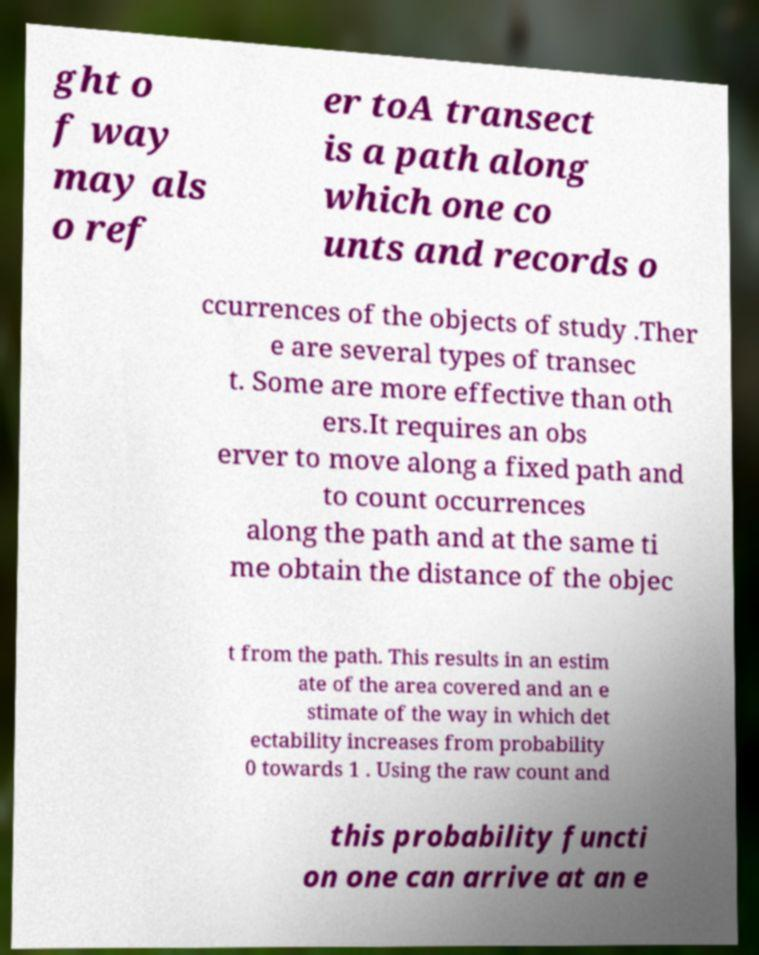Please read and relay the text visible in this image. What does it say? ght o f way may als o ref er toA transect is a path along which one co unts and records o ccurrences of the objects of study .Ther e are several types of transec t. Some are more effective than oth ers.It requires an obs erver to move along a fixed path and to count occurrences along the path and at the same ti me obtain the distance of the objec t from the path. This results in an estim ate of the area covered and an e stimate of the way in which det ectability increases from probability 0 towards 1 . Using the raw count and this probability functi on one can arrive at an e 